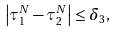<formula> <loc_0><loc_0><loc_500><loc_500>\left | \tau _ { 1 } ^ { N } - \tau _ { 2 } ^ { N } \right | \leq \delta _ { 3 } ,</formula> 